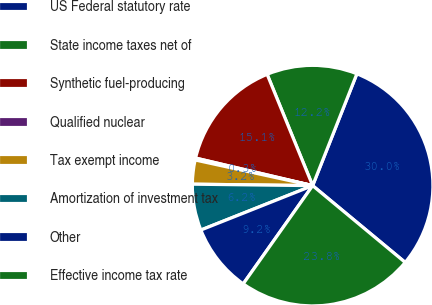Convert chart. <chart><loc_0><loc_0><loc_500><loc_500><pie_chart><fcel>US Federal statutory rate<fcel>State income taxes net of<fcel>Synthetic fuel-producing<fcel>Qualified nuclear<fcel>Tax exempt income<fcel>Amortization of investment tax<fcel>Other<fcel>Effective income tax rate<nl><fcel>30.03%<fcel>12.17%<fcel>15.14%<fcel>0.26%<fcel>3.23%<fcel>6.21%<fcel>9.19%<fcel>23.77%<nl></chart> 